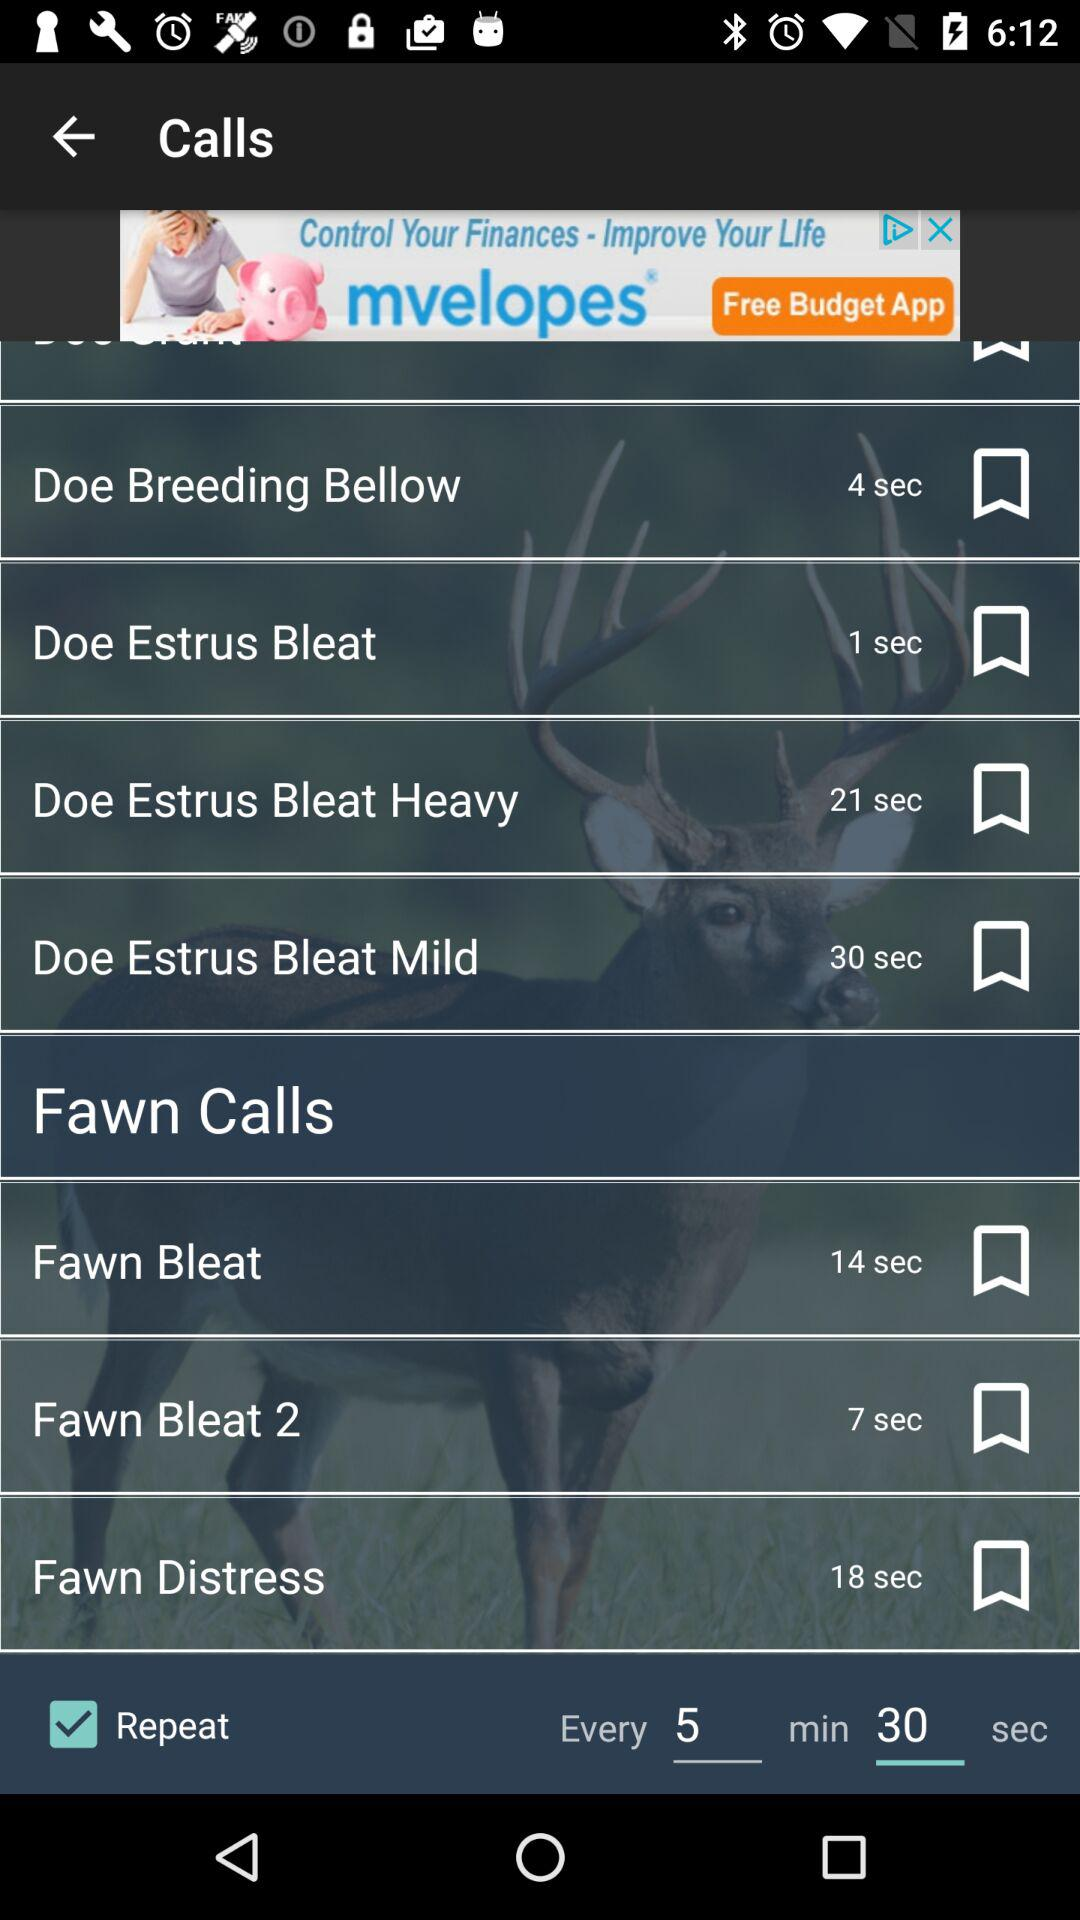What is the duration of the call "Doe Estrus Bleat"? The duration of the call is 1 second. 